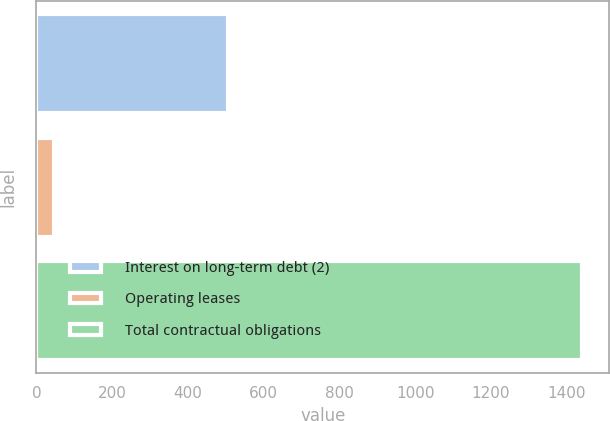Convert chart. <chart><loc_0><loc_0><loc_500><loc_500><bar_chart><fcel>Interest on long-term debt (2)<fcel>Operating leases<fcel>Total contractual obligations<nl><fcel>504.8<fcel>46.9<fcel>1440.7<nl></chart> 